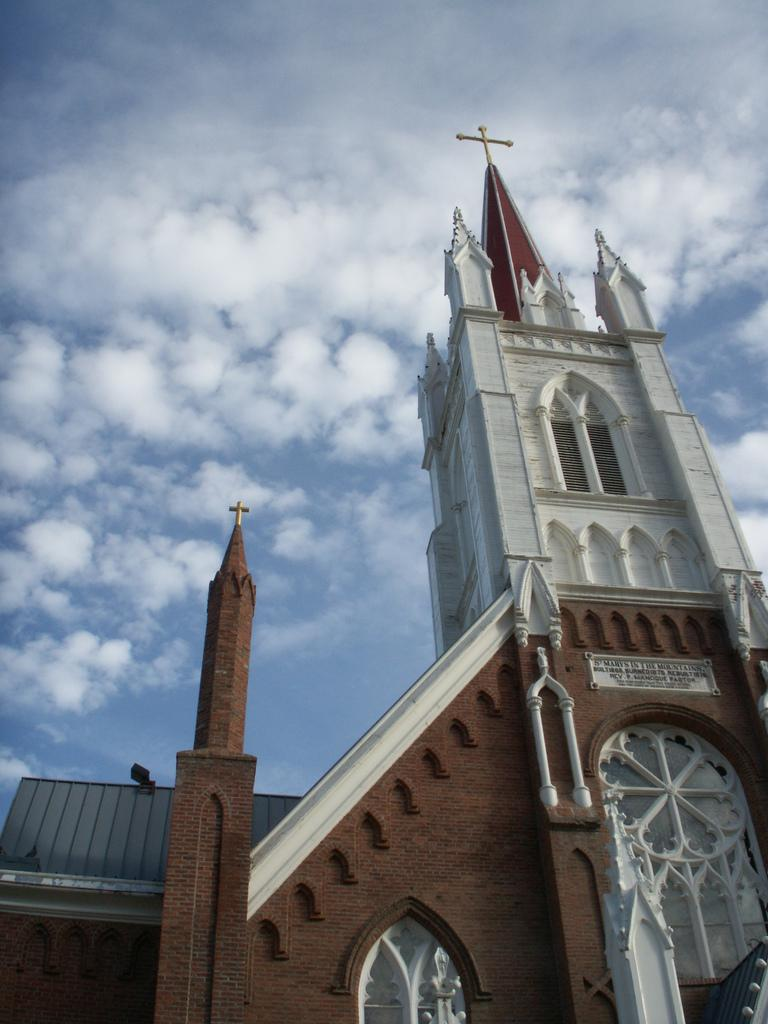What type of building is the main subject of the image? There is a church in the image. What is the most prominent feature of the church? There is a cross symbol at the top of the church. What can be seen in the background of the image? The sky is visible at the top of the image. What type of behavior is exhibited by the wine in the image? There is no wine present in the image, so it is not possible to determine its behavior. 